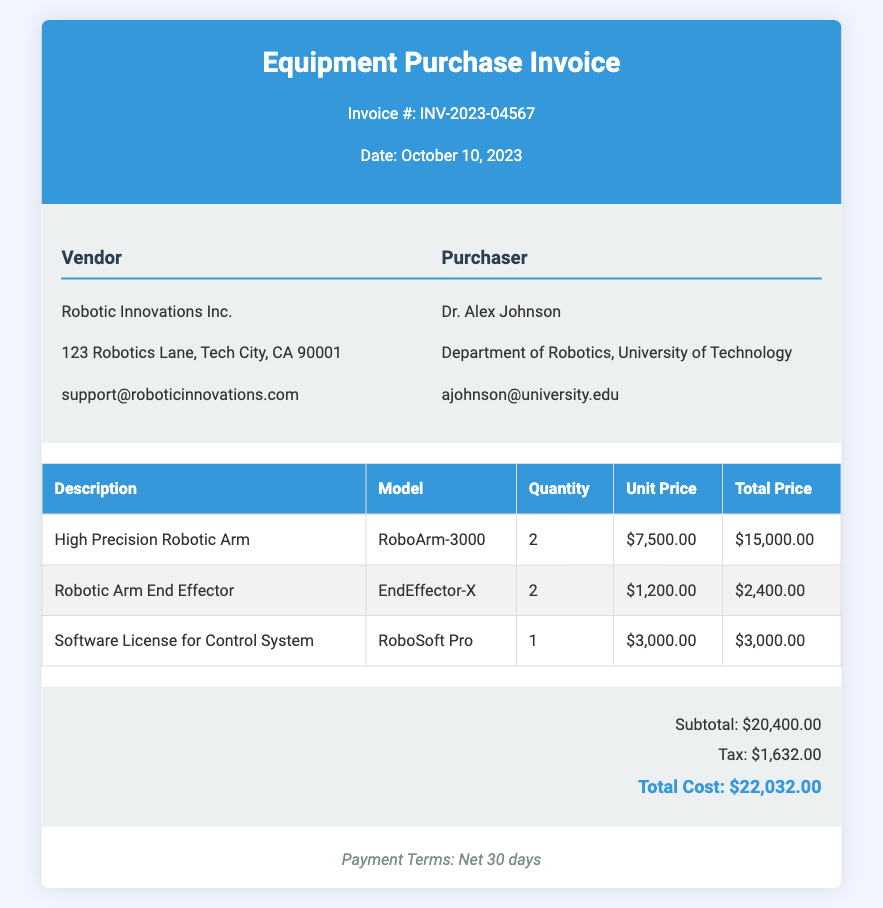What is the invoice number? The invoice number is listed at the top of the document under the title.
Answer: INV-2023-04567 Who is the vendor? The vendor details are provided in the invoice, specifically naming the company.
Answer: Robotic Innovations Inc What is the model of the high precision robotic arm? This model information is presented in the items table under the relevant description.
Answer: RoboArm-3000 How many robotic arm end effectors were purchased? The quantity for this item is clearly indicated in the items table.
Answer: 2 What is the subtotal amount before tax? The subtotal is calculated as the total of all item prices before tax, shown in the summary section.
Answer: $20,400.00 What is the total cost after tax? The total cost is the sum of the subtotal and tax displayed in the document.
Answer: $22,032.00 When is the payment due? The payment terms are listed at the bottom of the invoice, stating the specific payment timeframe.
Answer: Net 30 days How many total items are listed in the invoice? The invoice contains a direct count of the different items under the description column.
Answer: 3 What is the tax amount? The tax figure is specified in the summary section of the invoice.
Answer: $1,632.00 